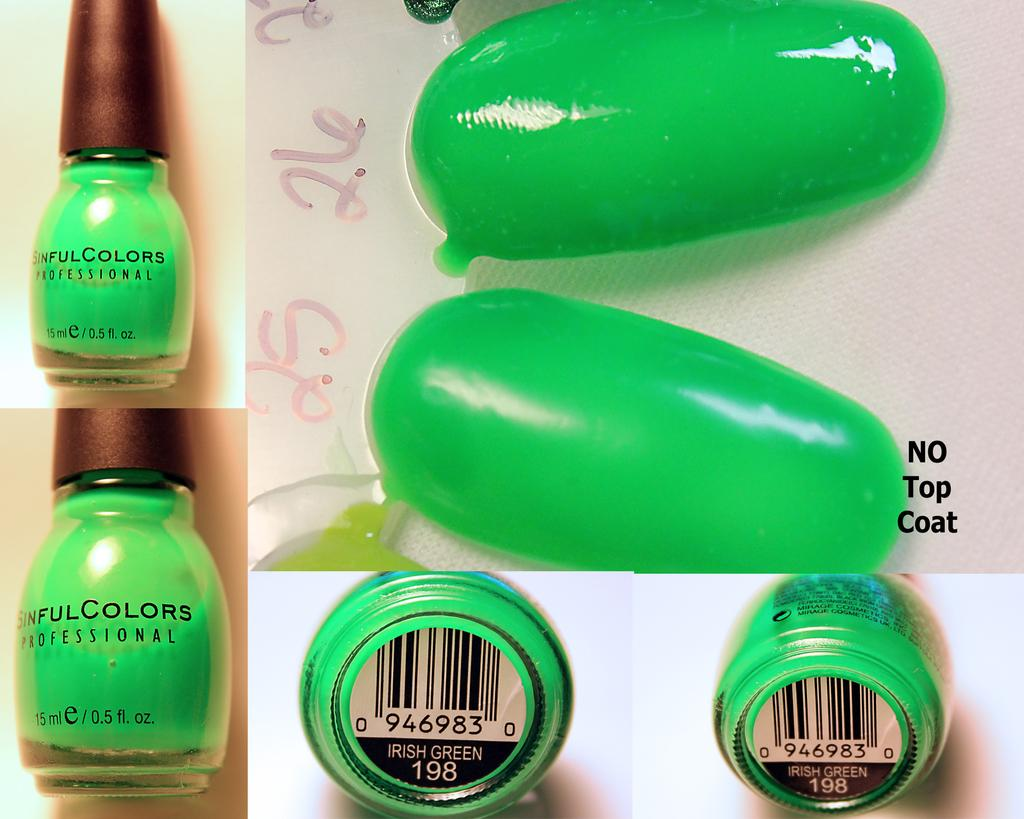<image>
Give a short and clear explanation of the subsequent image. nails painted in irish green from a nailpolish bottle labeled 'sinful colors' 